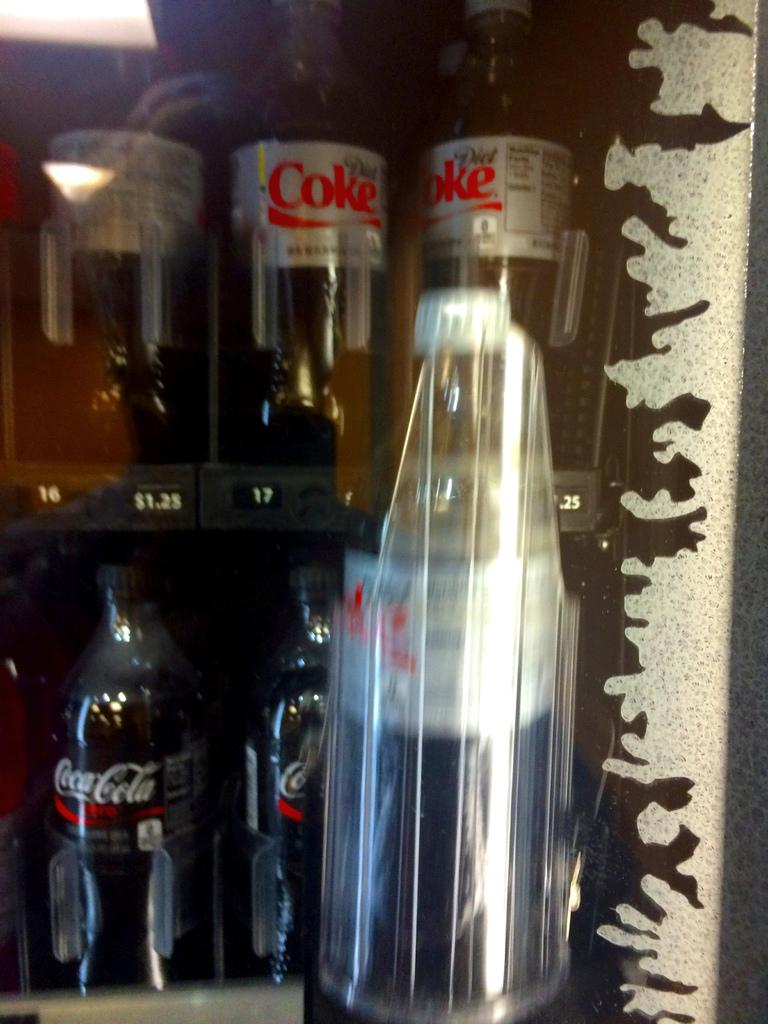<image>
Offer a succinct explanation of the picture presented. A selection of assorted Coca Cola products chill in a frosty refrigerator. 